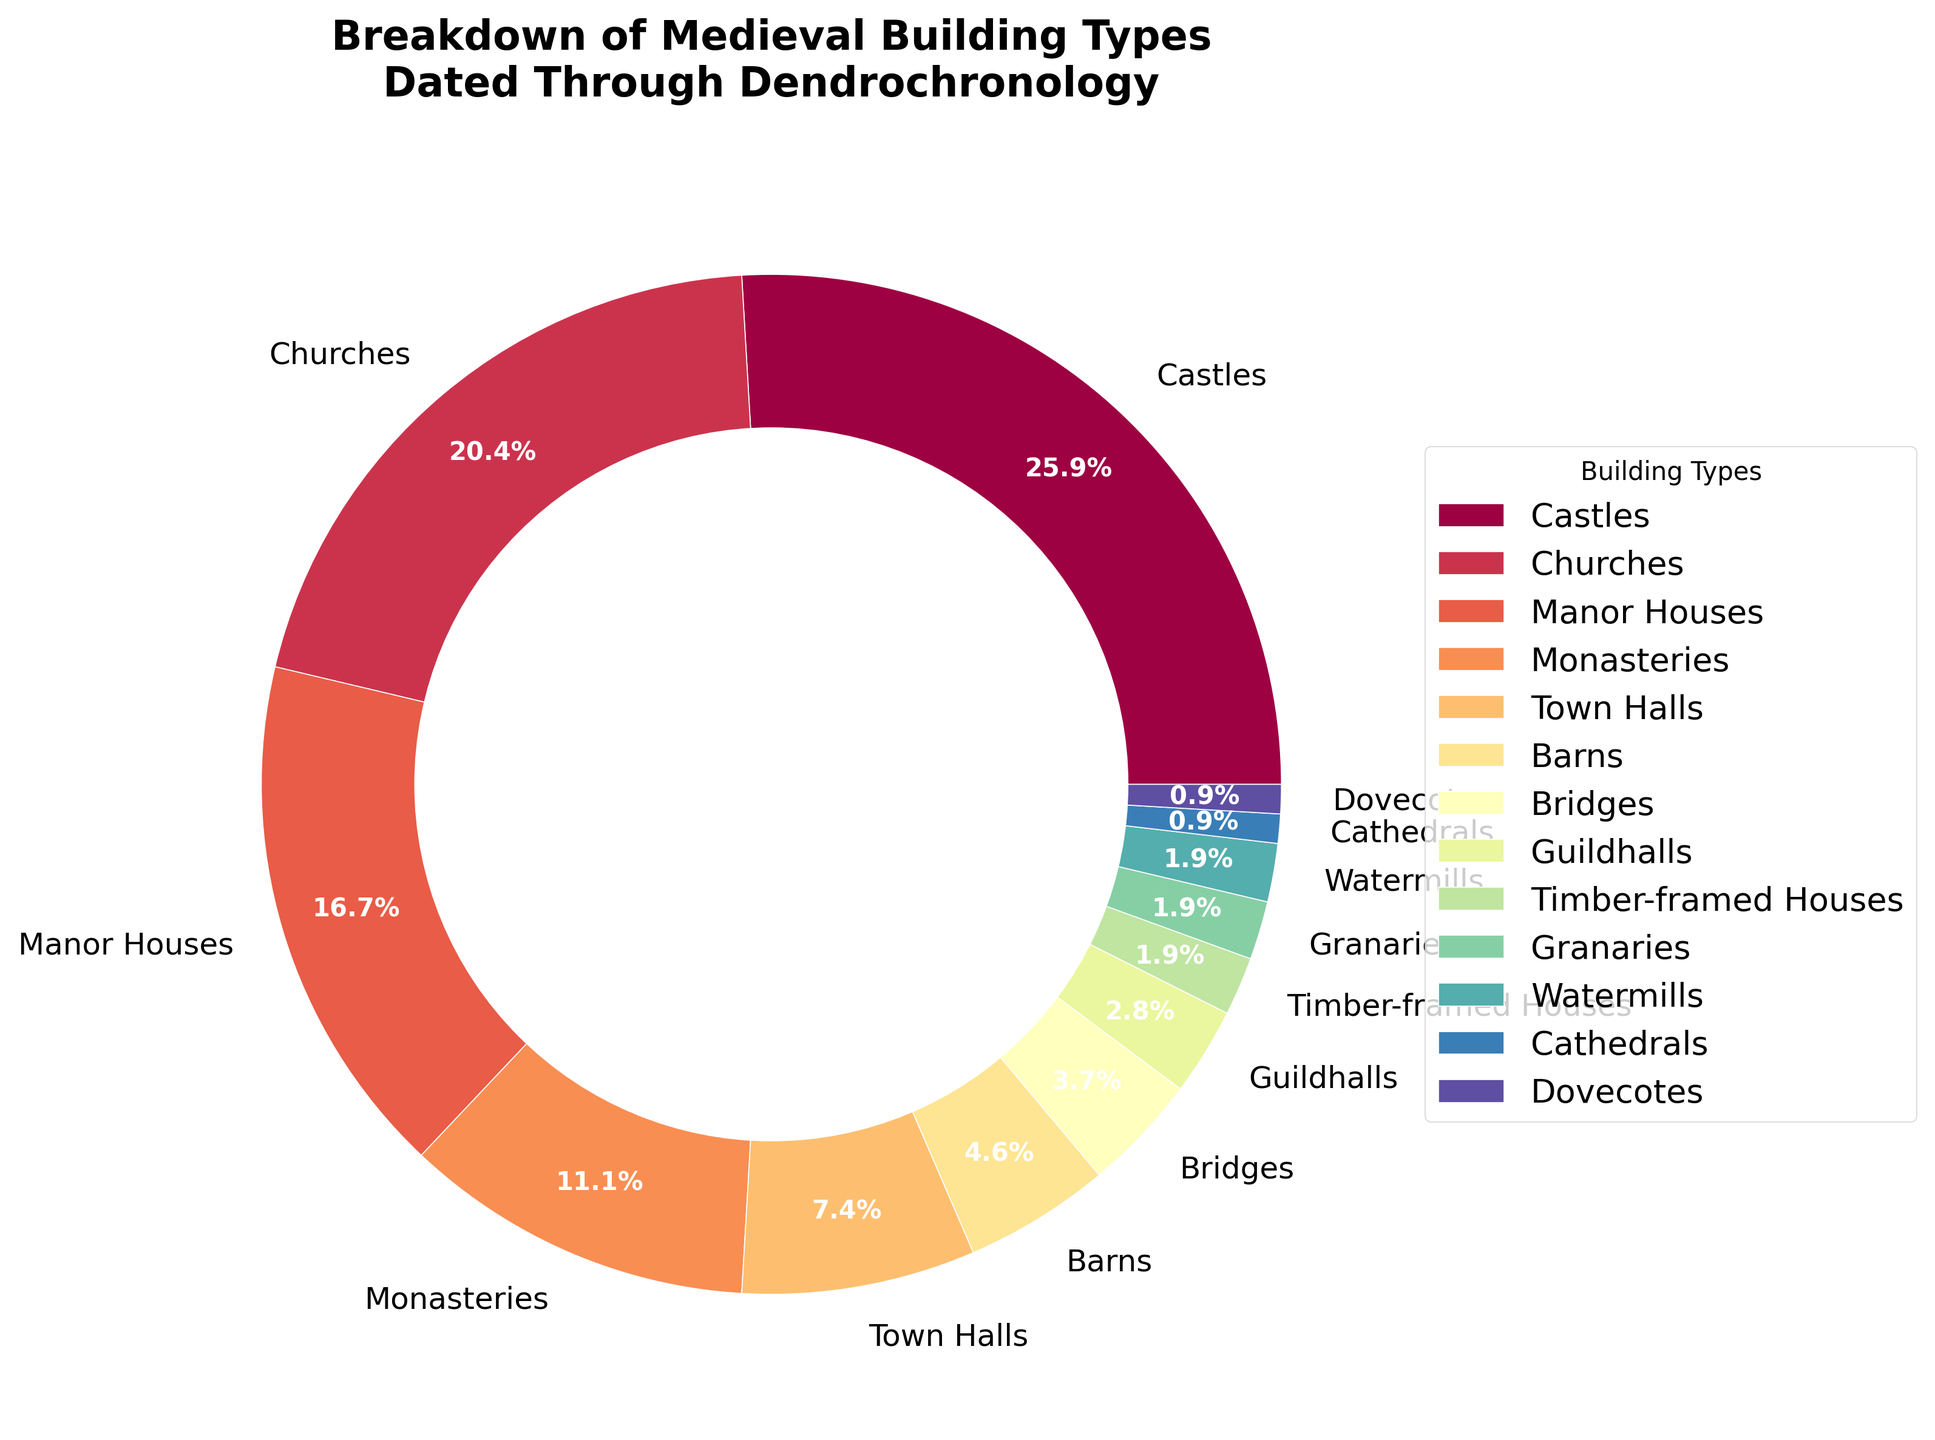Which building type has the highest percentage in the breakdown? The building type with the highest percentage can be identified by looking at the largest section of the pie chart. From the data, "Castles" have the highest percentage.
Answer: Castles Which building types have percentages less than 5%? To find the building types with percentages less than 5%, we look for the smaller slices of the pie chart and identify them in the legend. The building types that meet this criterion are "Barns," "Bridges," "Guildhalls," "Timber-framed Houses," "Granaries," "Watermills," "Cathedrals," and "Dovecotes."
Answer: Barns, Bridges, Guildhalls, Timber-framed Houses, Granaries, Watermills, Cathedrals, Dovecotes What is the combined percentage of Castles and Churches? We add the percentages of Castles and Churches: 28% + 22%. Adding these two values gives us the total combined percentage.
Answer: 50% How many building types have a percentage of 2%? By examining the pie chart and the legend, we count the building types with a 2% slice. These are "Timber-framed Houses," "Granaries," and "Watermills," so there are three building types with this percentage.
Answer: 3 Which type of building is represented by the yellow section in the pie chart? We identify the yellow section visually in the pie chart and match it to the corresponding building type in the legend. Upon inspecting the pie chart, the yellow section corresponds to "Monasteries."
Answer: Monasteries 